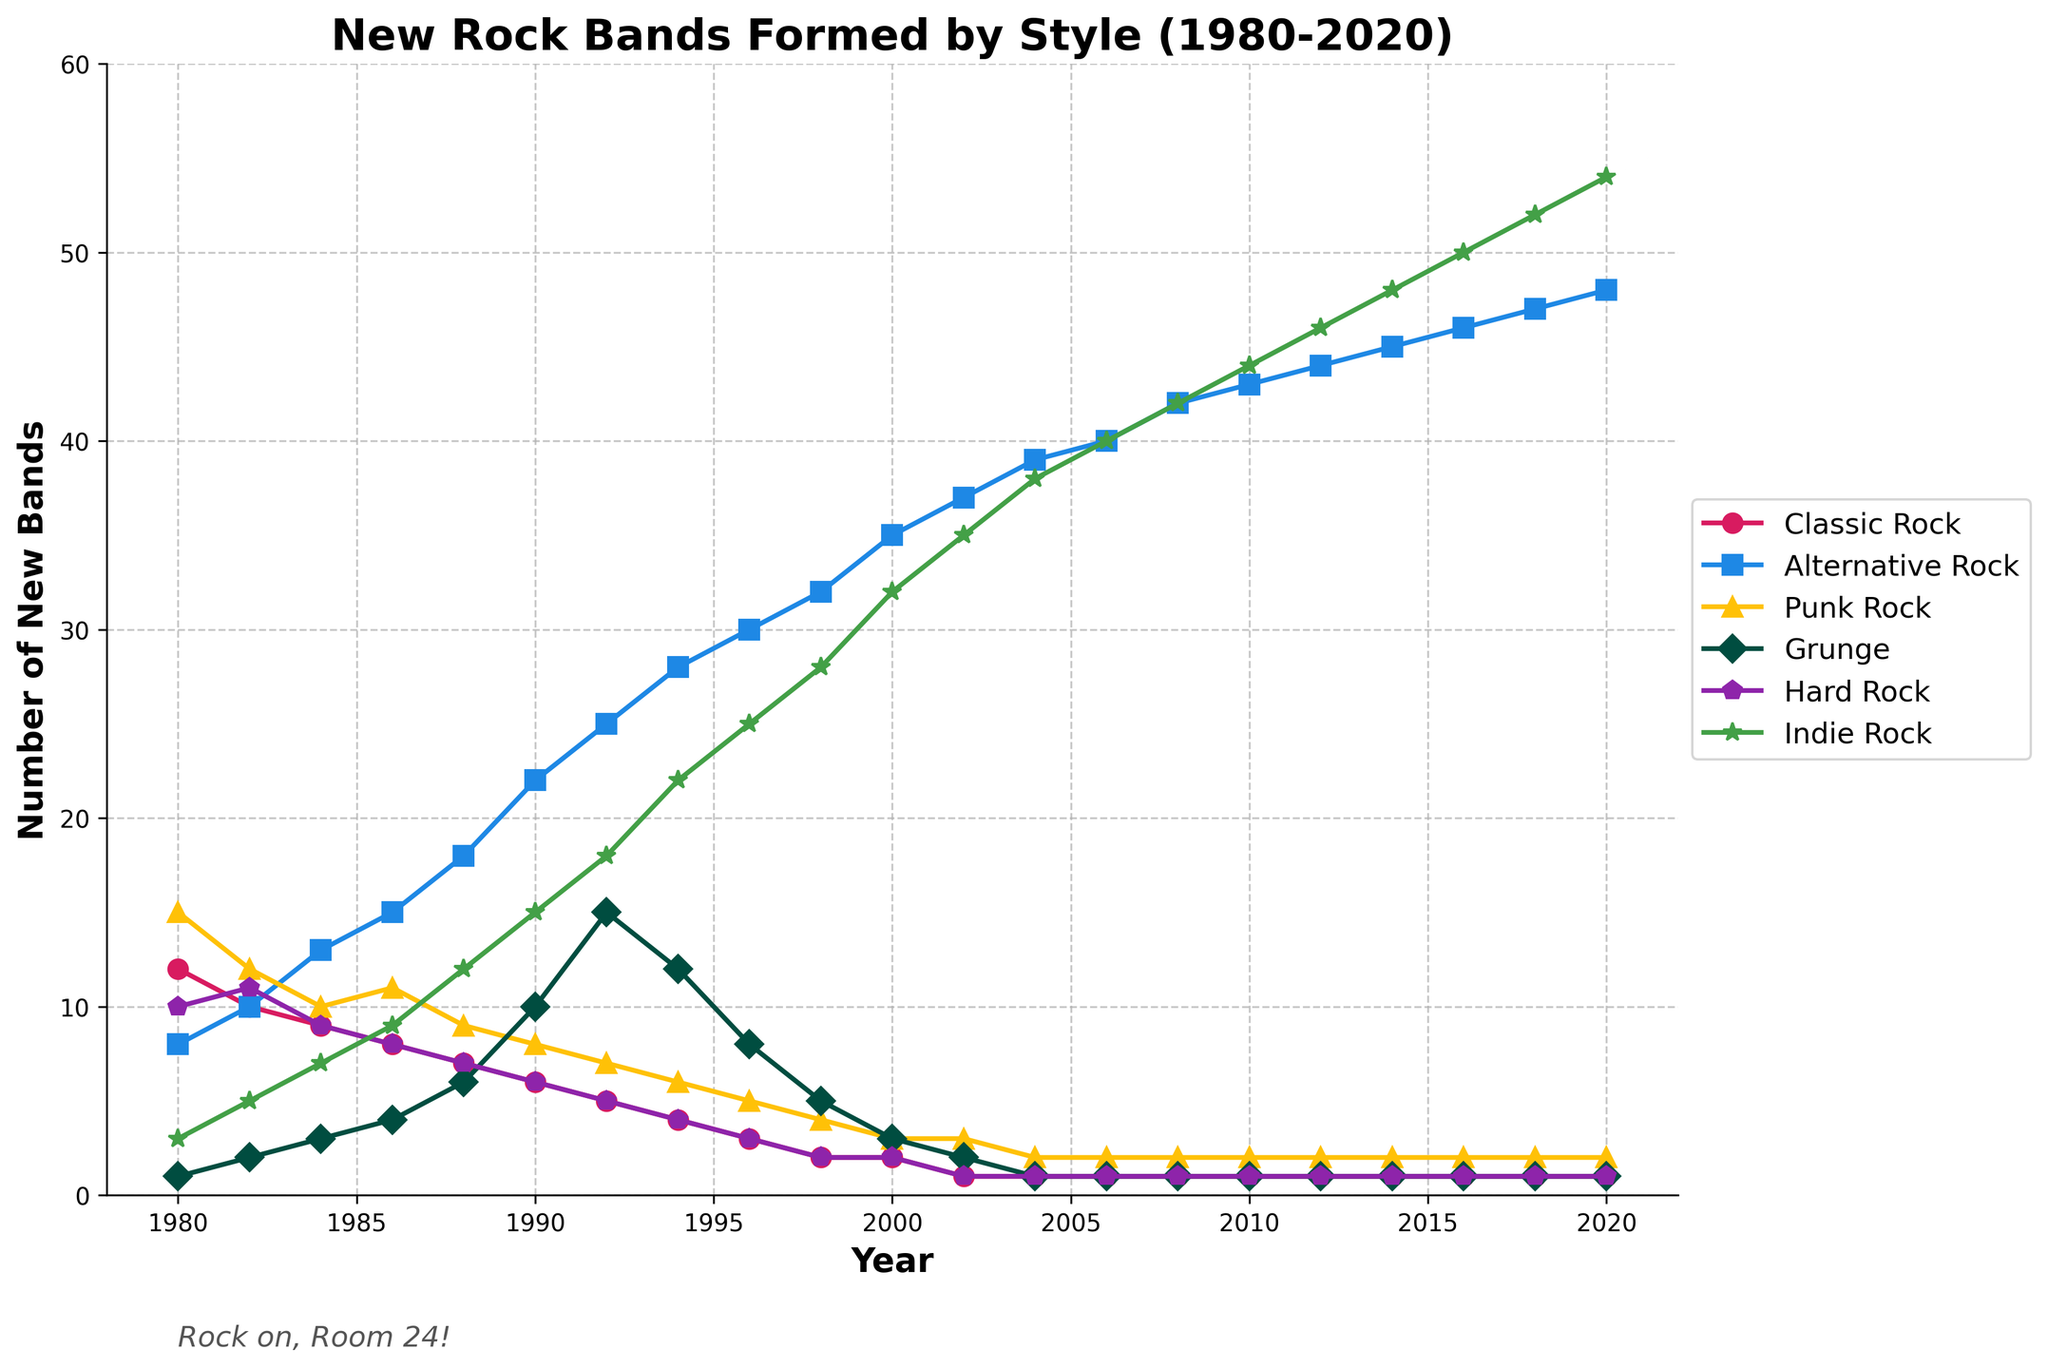Which musical style had the highest number of new bands formed in 2000? By looking at the graph under the year 2000, we notice that Alternative Rock has the highest peak compared to other styles with the number of new bands formed.
Answer: Alternative Rock Which musical style saw a significant drop in new bands formed after 1980 and remained low? From 1980 to subsequent years, Classic Rock shows a steep decline and eventually stabilizes at a low value.
Answer: Classic Rock What is the overall trend for Indie Rock bands formed from 1980 to 2020? Indie Rock shows a consistent upward trend throughout the years, with the number significantly increasing each decade.
Answer: Upward trend In which year did Grunge bands experience the most notable increase? Observing the graph, Grunge shows a notable rise between 1990 and 1992.
Answer: 1992 How does the number of new Alternative Rock bands formed in 1994 compare to 1984? In 1994, the number of new Alternative Rock bands is significantly higher than in 1984. In 1984, it's around 13, and in 1994, it's about 28.
Answer: 28 is higher than 13 Which musical style had minimal change in the number of new bands formed after 2002? After 2002, Classic Rock remained almost constant at around 1 new band formed every year.
Answer: Classic Rock What is the difference in the number of new Punk Rock bands formed between 1980 and 2000? In 1980, 15 new Punk Rock bands were formed, and in 2000, it dropped to 3. The difference is 15 - 3.
Answer: 12 How did the formation of Hard Rock bands evolve from 1980 to 2020? The number of new Hard Rock bands declined until around 1994 and then remained very low for the rest of the period.
Answer: Decline then stable What visual features distinguish the data for Alternative Rock? The Alternative Rock line is in blue, marked with square markers, and shows a consistent upward trajectory.
Answer: Blue, square markers, upward trajectory Between 1996 and 1998, which musical styles show a decreasing trend? By examining the graph, Classic Rock, Punk Rock, and Grunge show a decreasing number of new bands formed between 1996 and 1998.
Answer: Classic Rock, Punk Rock, Grunge 